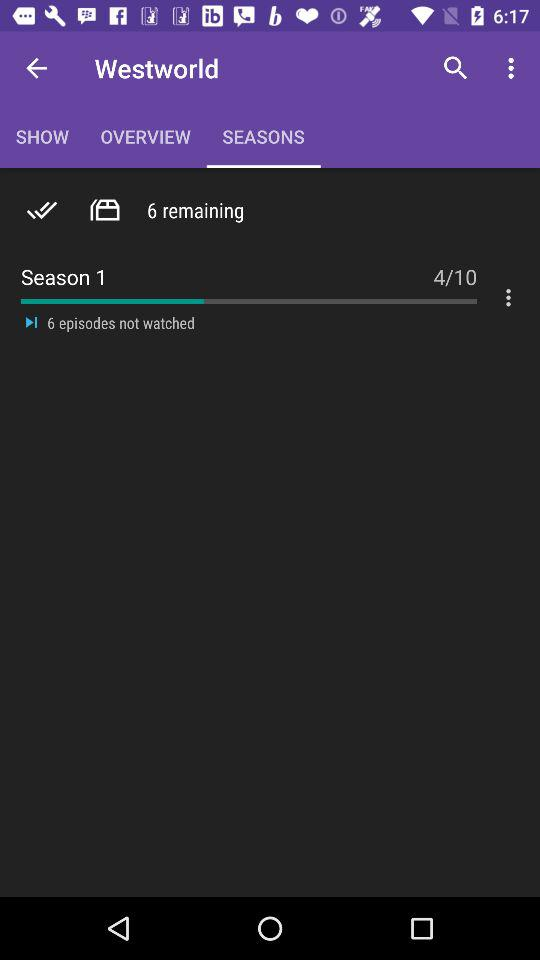Which tab has been selected? The selected tab is "SEASONS". 